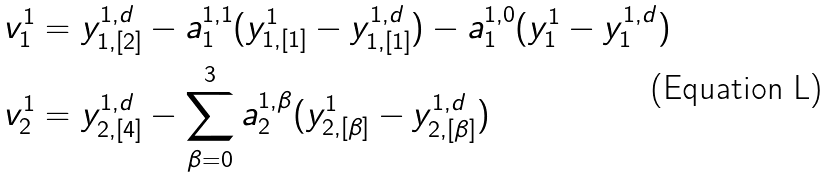<formula> <loc_0><loc_0><loc_500><loc_500>v _ { 1 } ^ { 1 } & = y _ { 1 , [ 2 ] } ^ { 1 , d } - a _ { 1 } ^ { 1 , 1 } ( y _ { 1 , [ 1 ] } ^ { 1 } - y _ { 1 , [ 1 ] } ^ { 1 , d } ) - a _ { 1 } ^ { 1 , 0 } ( y _ { 1 } ^ { 1 } - y _ { 1 } ^ { 1 , d } ) \\ v _ { 2 } ^ { 1 } & = y _ { 2 , [ 4 ] } ^ { 1 , d } - \sum _ { \beta = 0 } ^ { 3 } a _ { 2 } ^ { 1 , \beta } ( y _ { 2 , [ \beta ] } ^ { 1 } - y _ { 2 , [ \beta ] } ^ { 1 , d } )</formula> 